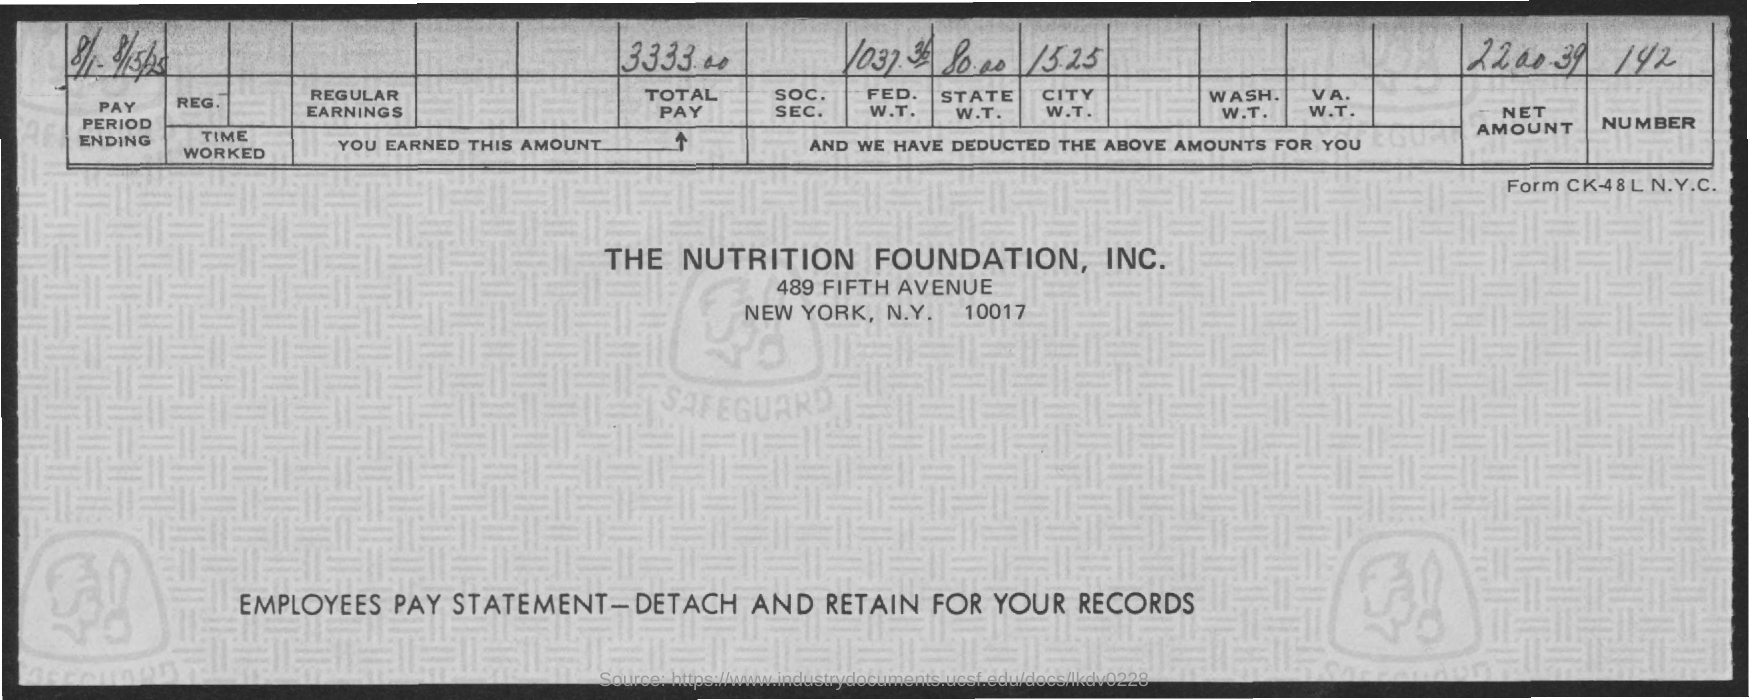What is the amount of total pay mentioned in the given page ?
Offer a terse response. 3333.00. What is the net amount mentioned in the given page ?
Keep it short and to the point. 2200.39. What is the amount for fed. w.t. as mentioned in the given page ?
Keep it short and to the point. 1037.36. What is the amount for state w.t. as mentioned in the given page ?
Keep it short and to the point. 80.00. What is the amount for city w.t. as mentioned in the given page ?
Keep it short and to the point. 15.25. 